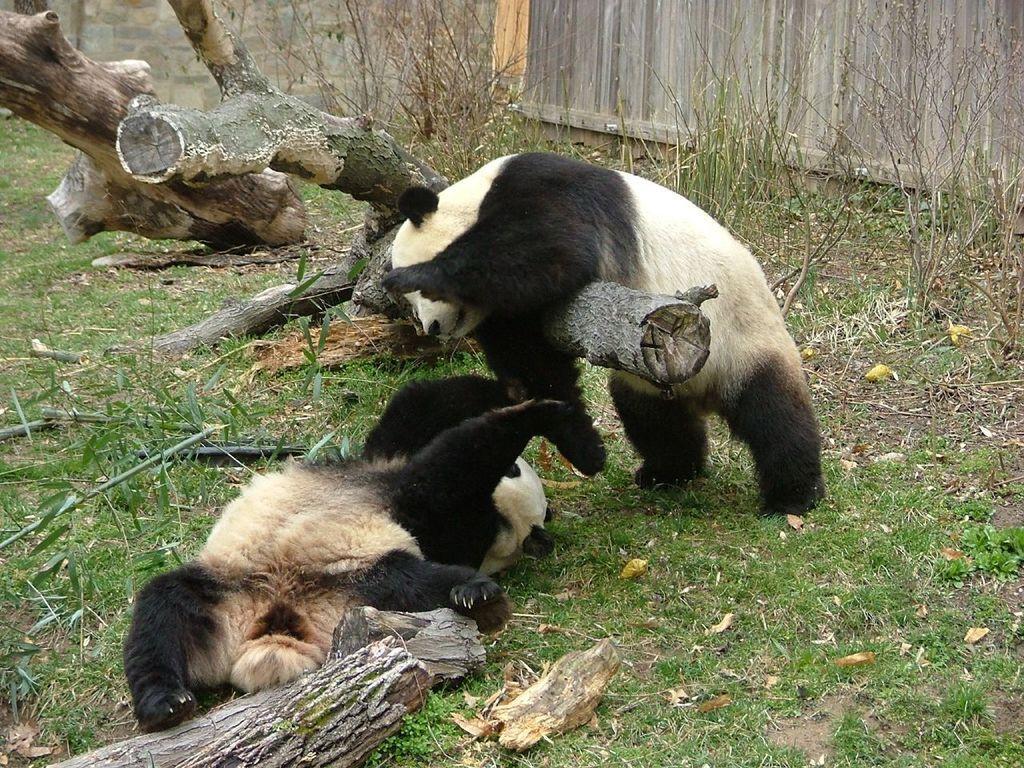How would you summarize this image in a sentence or two? Here we can see a panda lying on the ground at the log and another panda is standing on the ground and resting its body on a log. In the background we can see wall,wooden fence,grass and wooden logs. 